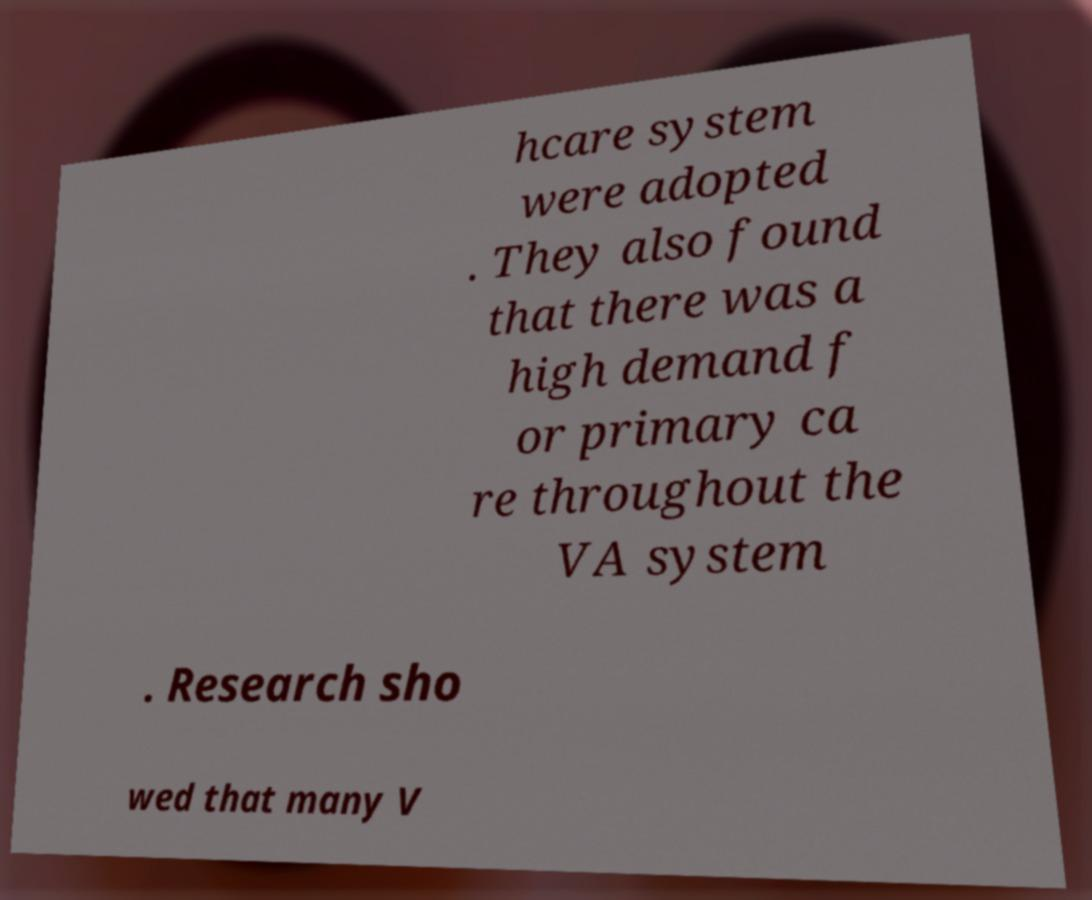Could you assist in decoding the text presented in this image and type it out clearly? hcare system were adopted . They also found that there was a high demand f or primary ca re throughout the VA system . Research sho wed that many V 